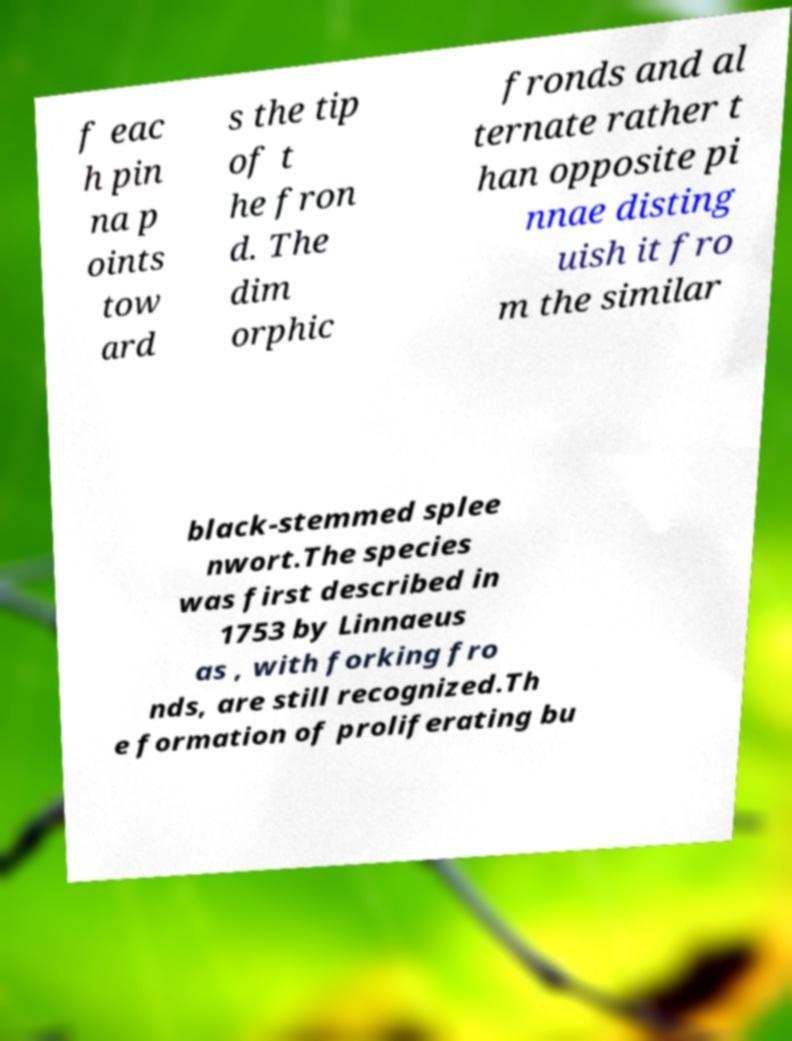Please identify and transcribe the text found in this image. f eac h pin na p oints tow ard s the tip of t he fron d. The dim orphic fronds and al ternate rather t han opposite pi nnae disting uish it fro m the similar black-stemmed splee nwort.The species was first described in 1753 by Linnaeus as , with forking fro nds, are still recognized.Th e formation of proliferating bu 